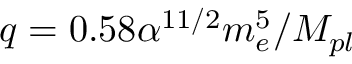Convert formula to latex. <formula><loc_0><loc_0><loc_500><loc_500>q = 0 . 5 8 \alpha ^ { 1 1 / 2 } m _ { e } ^ { 5 } / M _ { p l }</formula> 